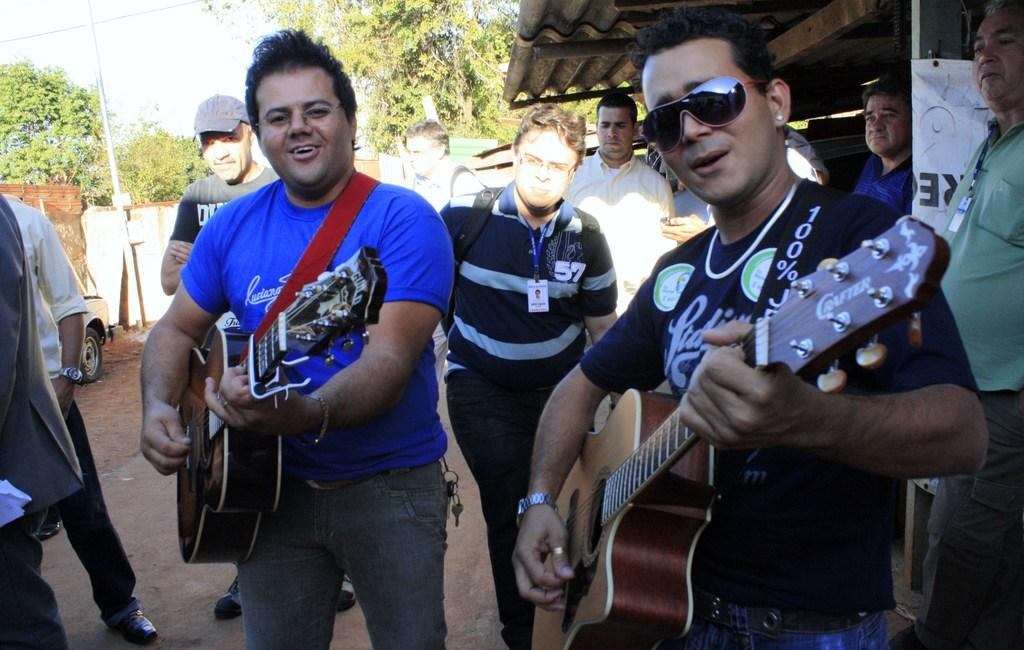What are the two men in the image doing? The two men in the image are playing guitar. Can you describe the background of the image? There are men walking in the background of the image. What type of sticks are the men using to play the guitar in the image? The men are not using sticks to play the guitar in the image; they are using their hands to strum the strings. Does the existence of the guitar players in the image prove the existence of a parallel universe? There is no information in the image or the provided facts to suggest the existence of a parallel universe, so we cannot make any conclusions about that. 